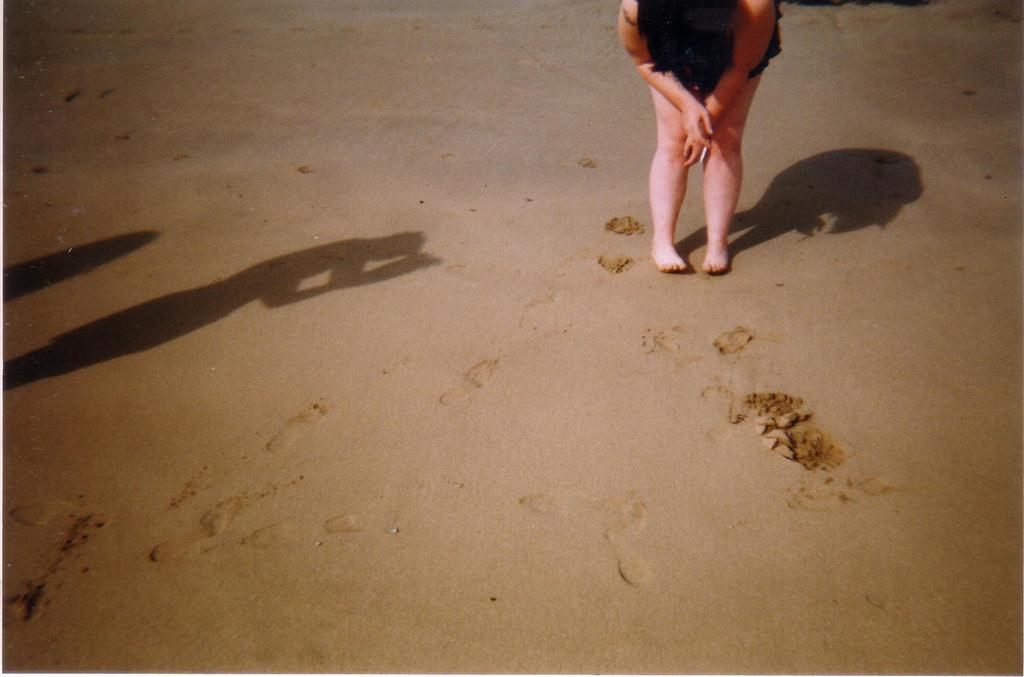What is the main subject of the image? There is a person standing on the sand at the top of the image. Can you describe any additional details about the person? The person's shadow is visible in the image. What can be seen on the left side of the image? There are shadows on the left side of the image. What type of blade is being used to cut the quince in the image? There is no blade or quince present in the image. How many toothbrushes can be seen in the image? There are no toothbrushes present in the image. 